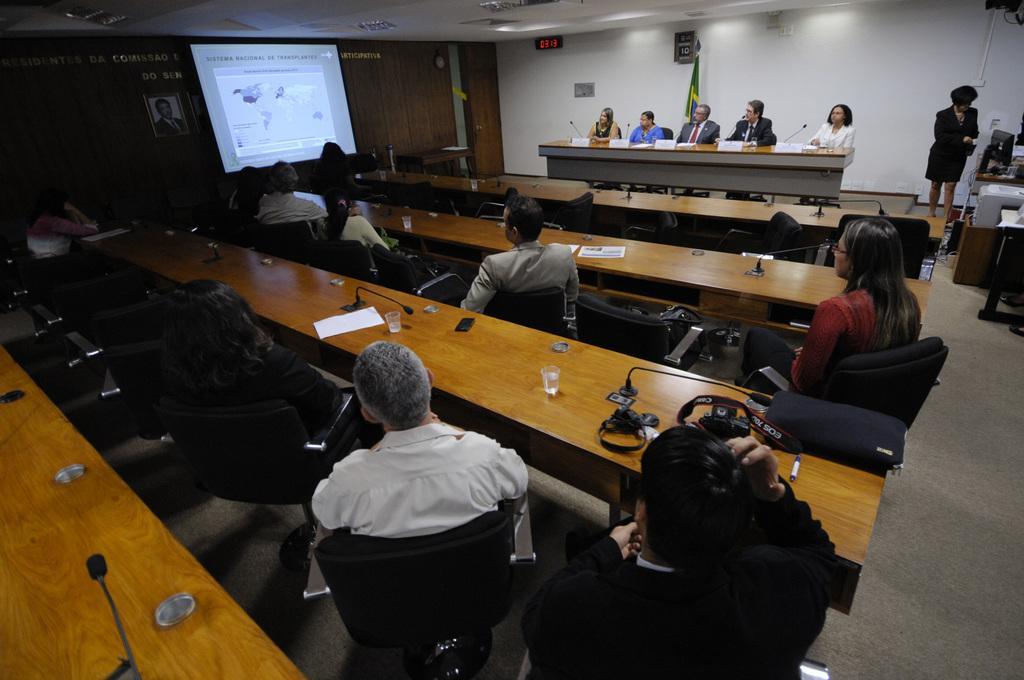Describe this image in one or two sentences. This picture taken in a conference hall, people are sitting in chairs in front of tables , there is presentation going on. 